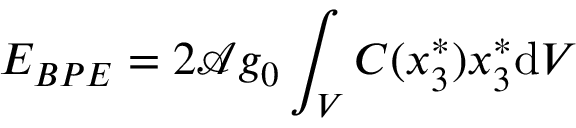Convert formula to latex. <formula><loc_0><loc_0><loc_500><loc_500>E _ { B P E } = 2 \mathcal { A } g _ { 0 } \int _ { V } C ( x _ { 3 } ^ { * } ) x _ { 3 } ^ { * } d V</formula> 